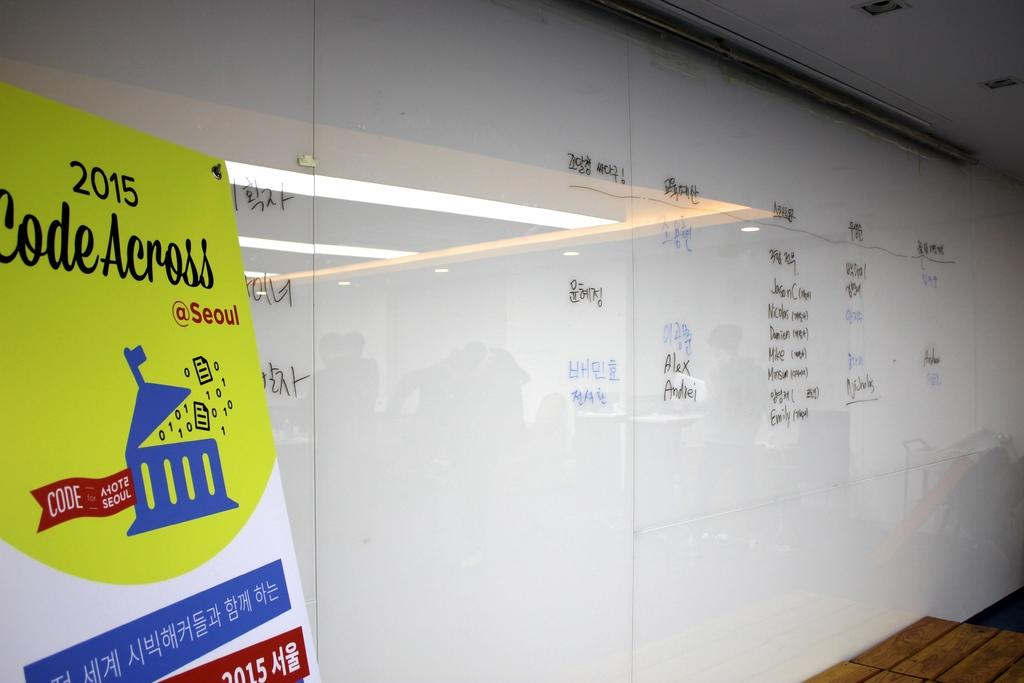Provide a one-sentence caption for the provided image. A large white board and a sign that says 2015 Code Across. 